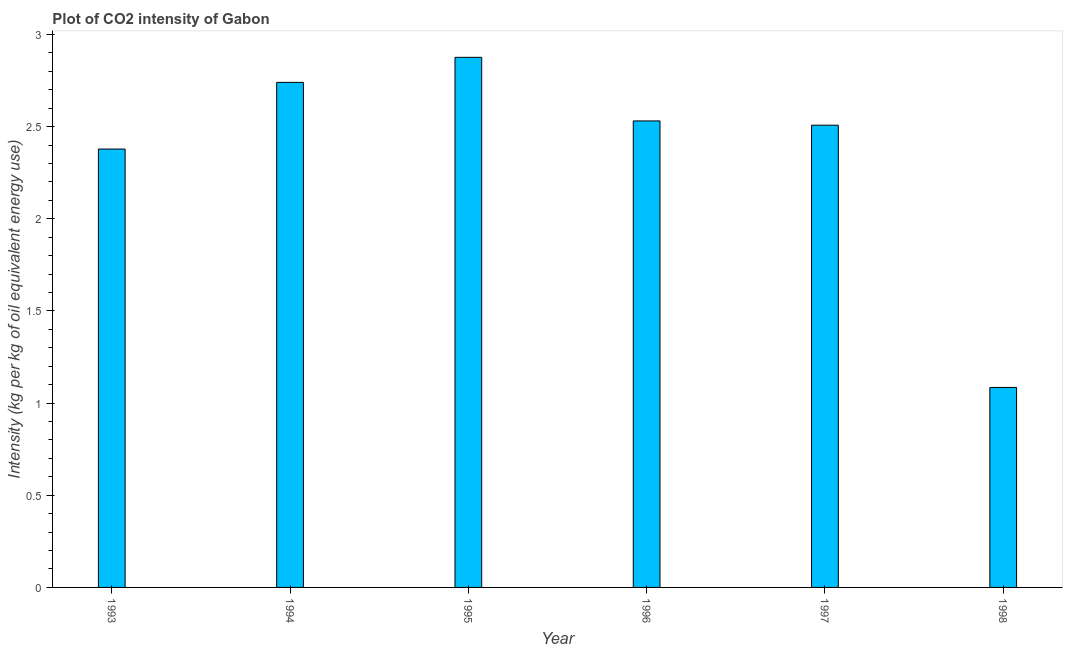Does the graph contain any zero values?
Give a very brief answer. No. What is the title of the graph?
Offer a terse response. Plot of CO2 intensity of Gabon. What is the label or title of the Y-axis?
Offer a terse response. Intensity (kg per kg of oil equivalent energy use). What is the co2 intensity in 1996?
Provide a succinct answer. 2.53. Across all years, what is the maximum co2 intensity?
Make the answer very short. 2.88. Across all years, what is the minimum co2 intensity?
Offer a very short reply. 1.09. In which year was the co2 intensity maximum?
Your response must be concise. 1995. In which year was the co2 intensity minimum?
Give a very brief answer. 1998. What is the sum of the co2 intensity?
Ensure brevity in your answer.  14.12. What is the difference between the co2 intensity in 1995 and 1997?
Your answer should be very brief. 0.37. What is the average co2 intensity per year?
Provide a short and direct response. 2.35. What is the median co2 intensity?
Your answer should be very brief. 2.52. In how many years, is the co2 intensity greater than 2 kg?
Ensure brevity in your answer.  5. Do a majority of the years between 1998 and 1995 (inclusive) have co2 intensity greater than 0.8 kg?
Offer a very short reply. Yes. What is the ratio of the co2 intensity in 1993 to that in 1995?
Your answer should be very brief. 0.83. Is the co2 intensity in 1994 less than that in 1996?
Offer a terse response. No. What is the difference between the highest and the second highest co2 intensity?
Give a very brief answer. 0.14. Is the sum of the co2 intensity in 1993 and 1998 greater than the maximum co2 intensity across all years?
Ensure brevity in your answer.  Yes. What is the difference between the highest and the lowest co2 intensity?
Make the answer very short. 1.79. In how many years, is the co2 intensity greater than the average co2 intensity taken over all years?
Provide a short and direct response. 5. How many bars are there?
Your response must be concise. 6. Are all the bars in the graph horizontal?
Provide a succinct answer. No. How many years are there in the graph?
Your answer should be compact. 6. Are the values on the major ticks of Y-axis written in scientific E-notation?
Offer a terse response. No. What is the Intensity (kg per kg of oil equivalent energy use) of 1993?
Provide a short and direct response. 2.38. What is the Intensity (kg per kg of oil equivalent energy use) of 1994?
Your response must be concise. 2.74. What is the Intensity (kg per kg of oil equivalent energy use) in 1995?
Your answer should be compact. 2.88. What is the Intensity (kg per kg of oil equivalent energy use) in 1996?
Your response must be concise. 2.53. What is the Intensity (kg per kg of oil equivalent energy use) in 1997?
Keep it short and to the point. 2.51. What is the Intensity (kg per kg of oil equivalent energy use) of 1998?
Your answer should be compact. 1.09. What is the difference between the Intensity (kg per kg of oil equivalent energy use) in 1993 and 1994?
Provide a succinct answer. -0.36. What is the difference between the Intensity (kg per kg of oil equivalent energy use) in 1993 and 1995?
Keep it short and to the point. -0.5. What is the difference between the Intensity (kg per kg of oil equivalent energy use) in 1993 and 1996?
Give a very brief answer. -0.15. What is the difference between the Intensity (kg per kg of oil equivalent energy use) in 1993 and 1997?
Keep it short and to the point. -0.13. What is the difference between the Intensity (kg per kg of oil equivalent energy use) in 1993 and 1998?
Your answer should be compact. 1.29. What is the difference between the Intensity (kg per kg of oil equivalent energy use) in 1994 and 1995?
Your answer should be compact. -0.14. What is the difference between the Intensity (kg per kg of oil equivalent energy use) in 1994 and 1996?
Keep it short and to the point. 0.21. What is the difference between the Intensity (kg per kg of oil equivalent energy use) in 1994 and 1997?
Your response must be concise. 0.23. What is the difference between the Intensity (kg per kg of oil equivalent energy use) in 1994 and 1998?
Give a very brief answer. 1.66. What is the difference between the Intensity (kg per kg of oil equivalent energy use) in 1995 and 1996?
Give a very brief answer. 0.35. What is the difference between the Intensity (kg per kg of oil equivalent energy use) in 1995 and 1997?
Make the answer very short. 0.37. What is the difference between the Intensity (kg per kg of oil equivalent energy use) in 1995 and 1998?
Your response must be concise. 1.79. What is the difference between the Intensity (kg per kg of oil equivalent energy use) in 1996 and 1997?
Your answer should be very brief. 0.02. What is the difference between the Intensity (kg per kg of oil equivalent energy use) in 1996 and 1998?
Keep it short and to the point. 1.45. What is the difference between the Intensity (kg per kg of oil equivalent energy use) in 1997 and 1998?
Provide a succinct answer. 1.42. What is the ratio of the Intensity (kg per kg of oil equivalent energy use) in 1993 to that in 1994?
Offer a terse response. 0.87. What is the ratio of the Intensity (kg per kg of oil equivalent energy use) in 1993 to that in 1995?
Your response must be concise. 0.83. What is the ratio of the Intensity (kg per kg of oil equivalent energy use) in 1993 to that in 1997?
Your answer should be compact. 0.95. What is the ratio of the Intensity (kg per kg of oil equivalent energy use) in 1993 to that in 1998?
Offer a terse response. 2.19. What is the ratio of the Intensity (kg per kg of oil equivalent energy use) in 1994 to that in 1995?
Your response must be concise. 0.95. What is the ratio of the Intensity (kg per kg of oil equivalent energy use) in 1994 to that in 1996?
Your response must be concise. 1.08. What is the ratio of the Intensity (kg per kg of oil equivalent energy use) in 1994 to that in 1997?
Ensure brevity in your answer.  1.09. What is the ratio of the Intensity (kg per kg of oil equivalent energy use) in 1994 to that in 1998?
Offer a very short reply. 2.53. What is the ratio of the Intensity (kg per kg of oil equivalent energy use) in 1995 to that in 1996?
Provide a succinct answer. 1.14. What is the ratio of the Intensity (kg per kg of oil equivalent energy use) in 1995 to that in 1997?
Your response must be concise. 1.15. What is the ratio of the Intensity (kg per kg of oil equivalent energy use) in 1995 to that in 1998?
Provide a succinct answer. 2.65. What is the ratio of the Intensity (kg per kg of oil equivalent energy use) in 1996 to that in 1998?
Make the answer very short. 2.33. What is the ratio of the Intensity (kg per kg of oil equivalent energy use) in 1997 to that in 1998?
Offer a terse response. 2.31. 